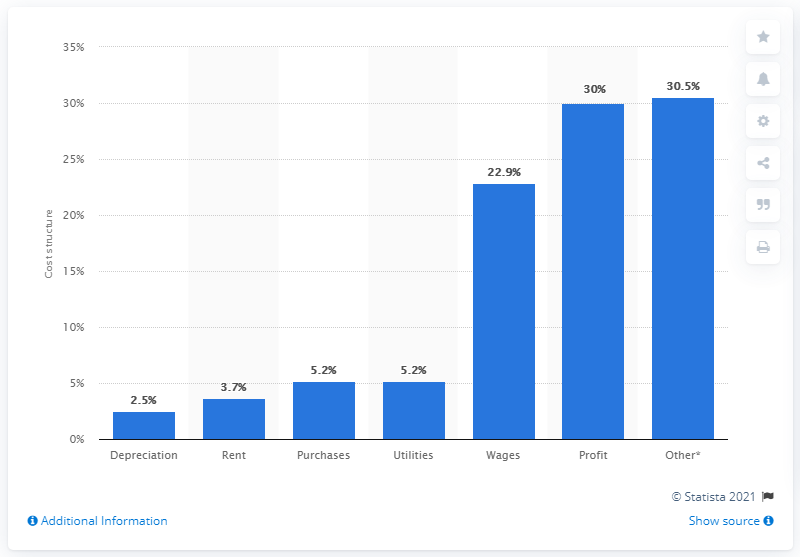Specify some key components in this picture. In 2010, approximately 3.7% of the total cost of the RV park industry was spent on rent. 